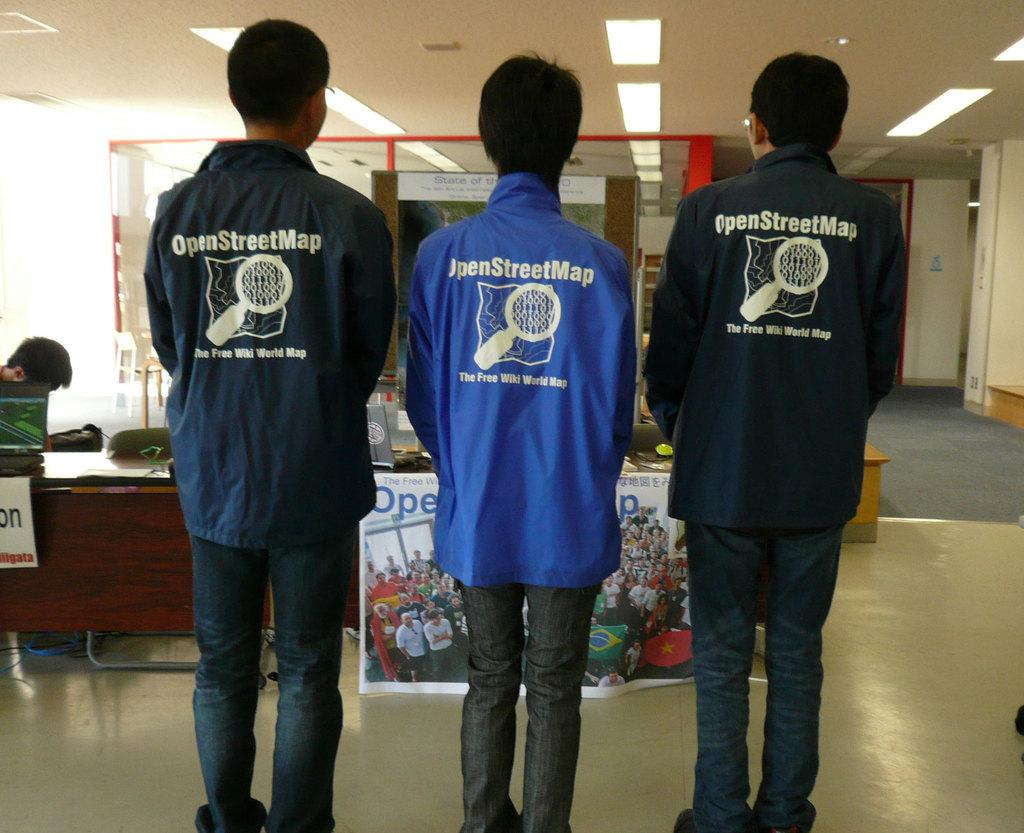<image>
Describe the image concisely. Open Street Map, The Free Wiki World Map is advertised on the back of these three jackets. 